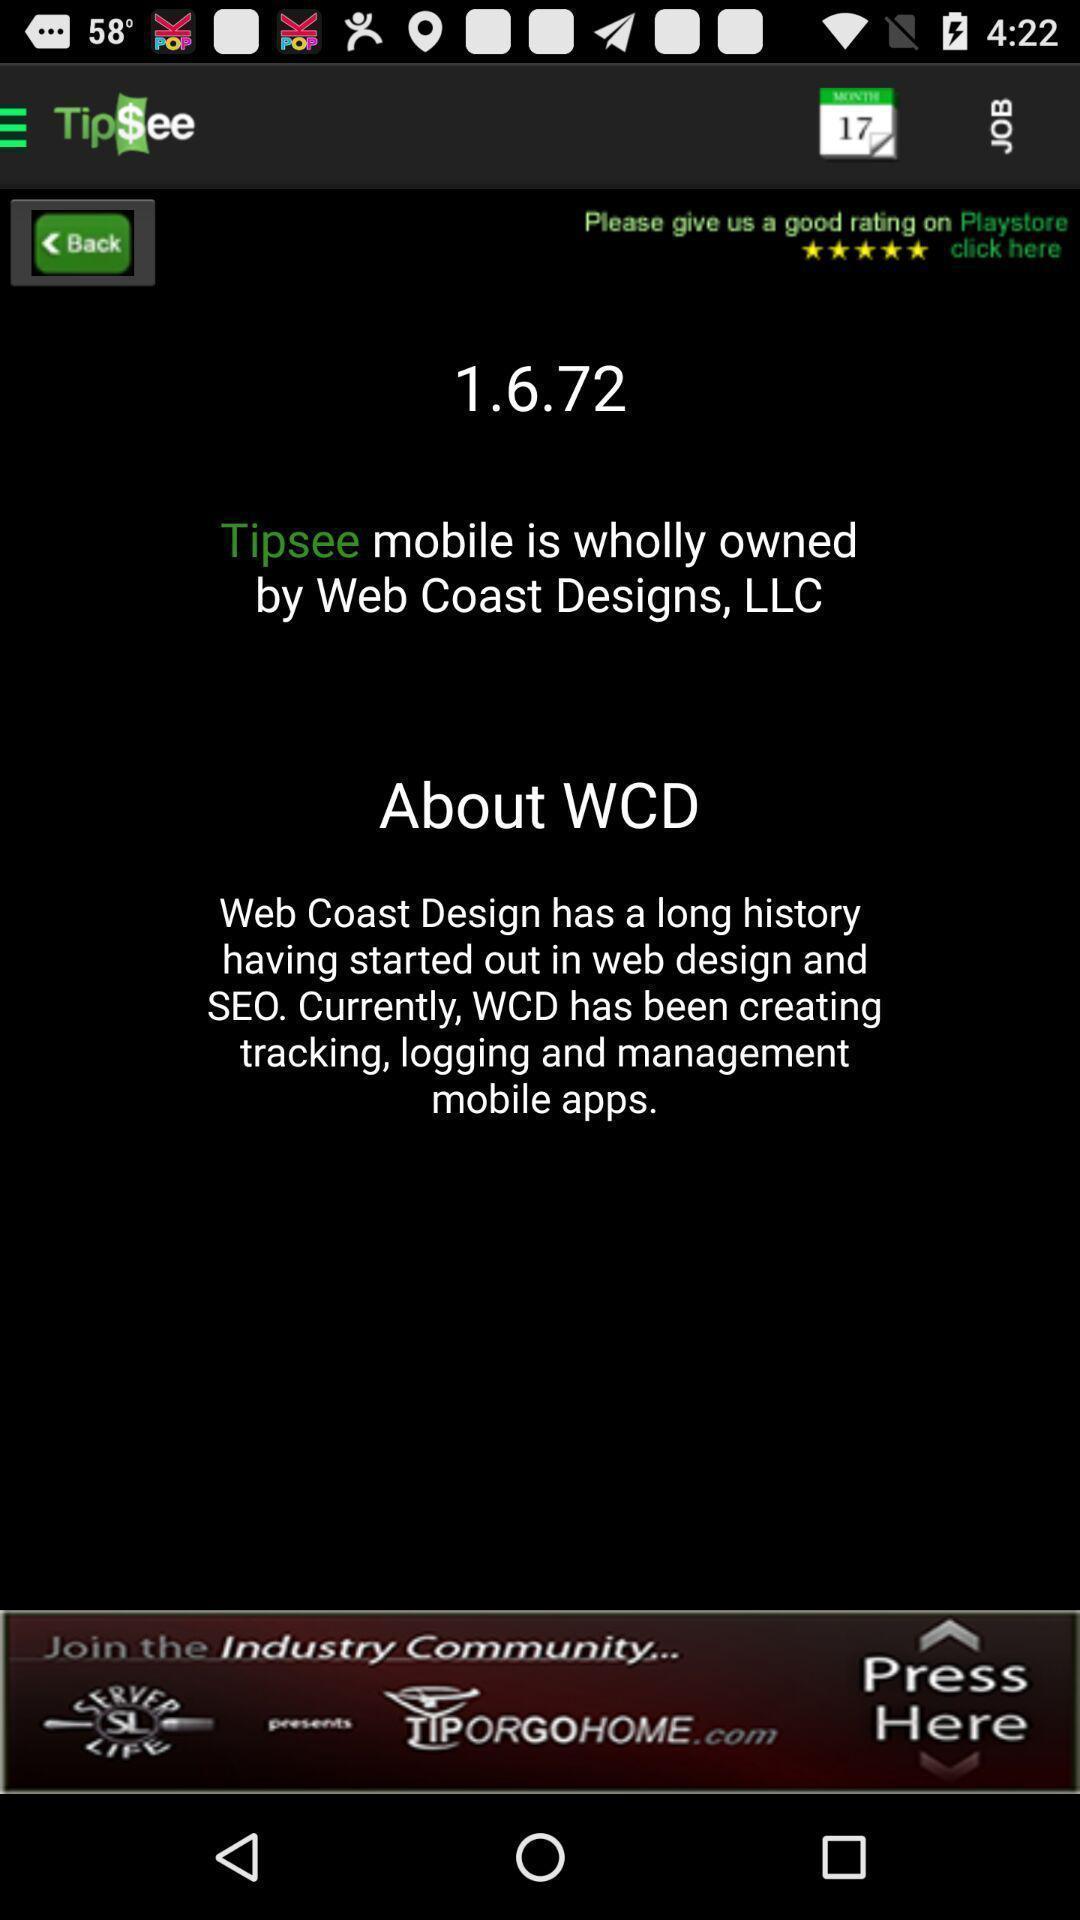Provide a textual representation of this image. Page is showing information about tip tracking app. 